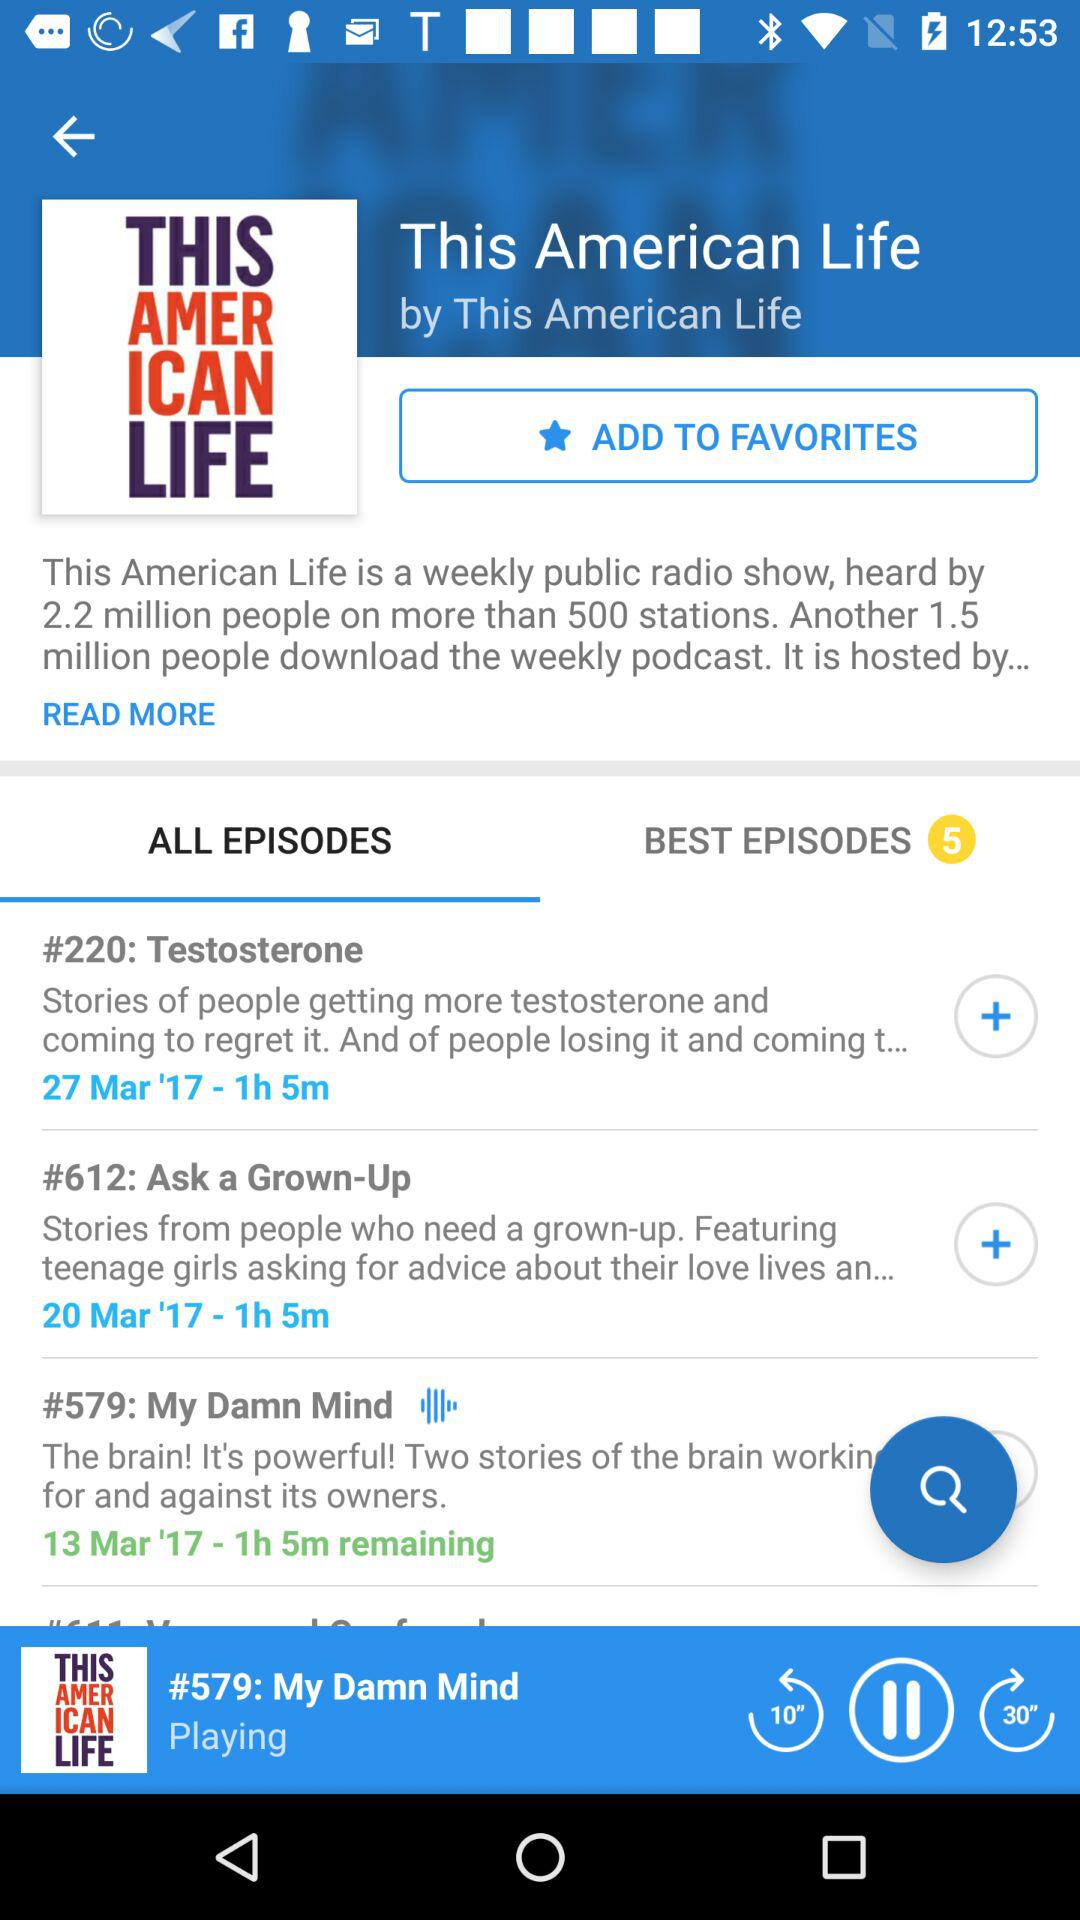What is "This American Life"? "This American Life" is a weekly public radio show. 